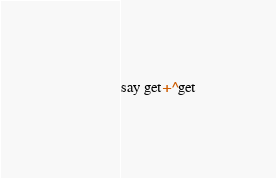<code> <loc_0><loc_0><loc_500><loc_500><_Perl_>say get+^get</code> 